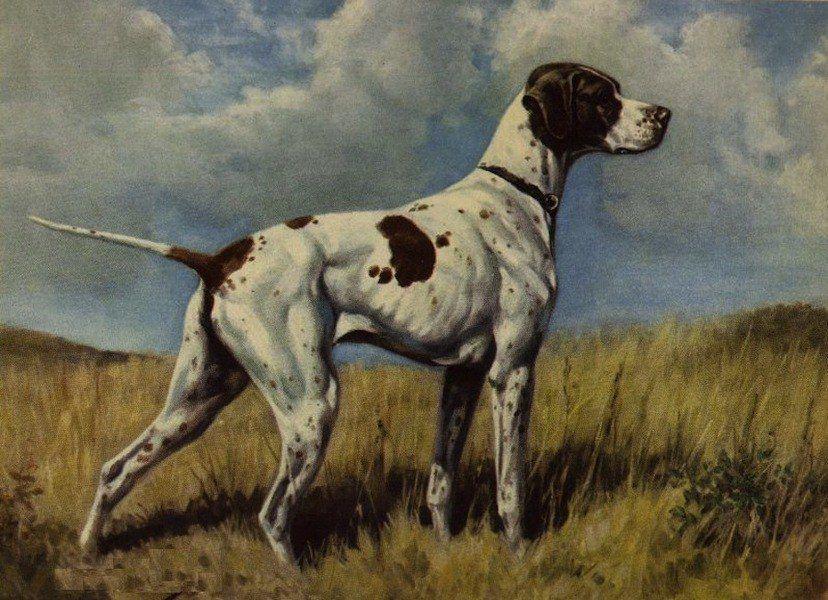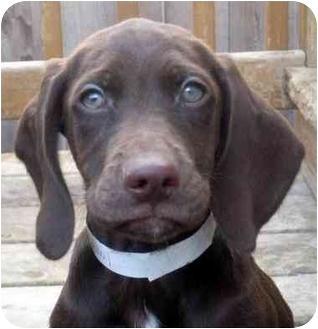The first image is the image on the left, the second image is the image on the right. Analyze the images presented: Is the assertion "One image shows a single puppy while the other shows a litter of at least five." valid? Answer yes or no. No. The first image is the image on the left, the second image is the image on the right. Assess this claim about the two images: "There is one dog in the left image and multiple dogs in the right image.". Correct or not? Answer yes or no. No. 